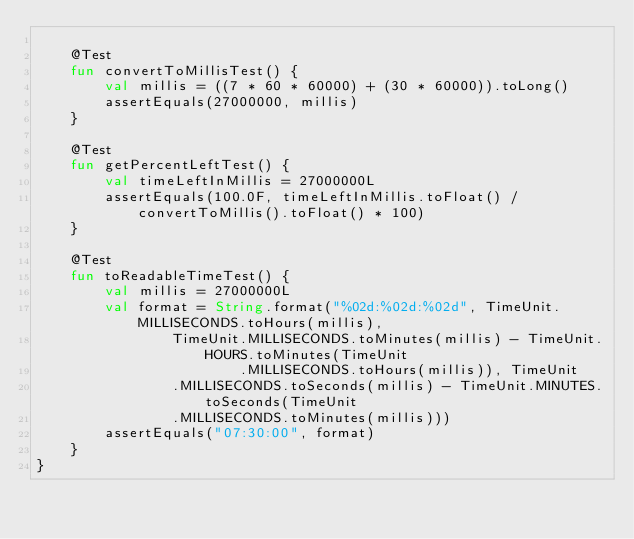<code> <loc_0><loc_0><loc_500><loc_500><_Kotlin_>
    @Test
    fun convertToMillisTest() {
        val millis = ((7 * 60 * 60000) + (30 * 60000)).toLong()
        assertEquals(27000000, millis)
    }

    @Test
    fun getPercentLeftTest() {
        val timeLeftInMillis = 27000000L
        assertEquals(100.0F, timeLeftInMillis.toFloat() / convertToMillis().toFloat() * 100)
    }

    @Test
    fun toReadableTimeTest() {
        val millis = 27000000L
        val format = String.format("%02d:%02d:%02d", TimeUnit.MILLISECONDS.toHours(millis),
                TimeUnit.MILLISECONDS.toMinutes(millis) - TimeUnit.HOURS.toMinutes(TimeUnit
                        .MILLISECONDS.toHours(millis)), TimeUnit
                .MILLISECONDS.toSeconds(millis) - TimeUnit.MINUTES.toSeconds(TimeUnit
                .MILLISECONDS.toMinutes(millis)))
        assertEquals("07:30:00", format)
    }
}</code> 